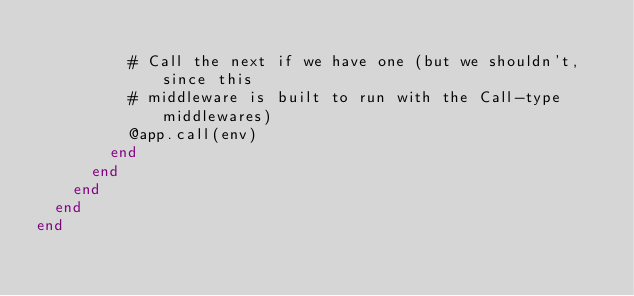<code> <loc_0><loc_0><loc_500><loc_500><_Ruby_>
          # Call the next if we have one (but we shouldn't, since this
          # middleware is built to run with the Call-type middlewares)
          @app.call(env)
        end
      end
    end
  end
end
</code> 